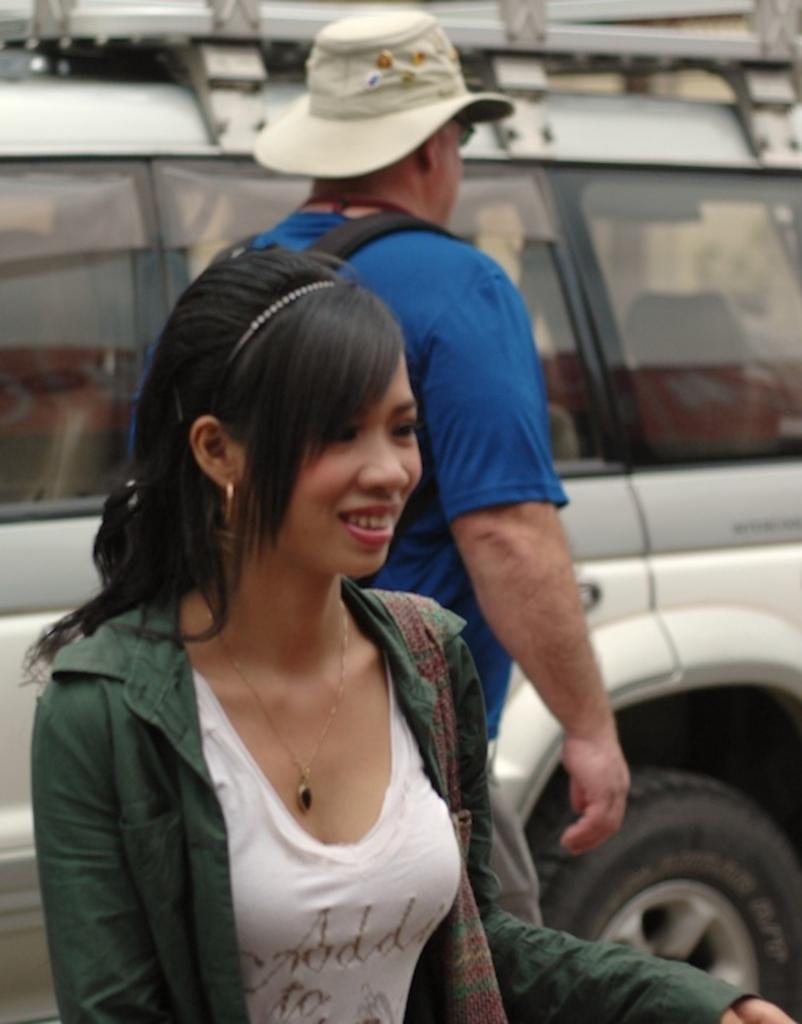How many people are present in the image? There are two persons in the image. Can you describe the vehicle in the background of the image? Unfortunately, the facts provided do not give any details about the vehicle in the background. What might the two persons be doing together? Without more context, it is difficult to determine what the two persons are doing together. Can you tell me how the monkey is balancing on the father's head in the image? There is no monkey or father present in the image, so this scenario cannot be observed. 